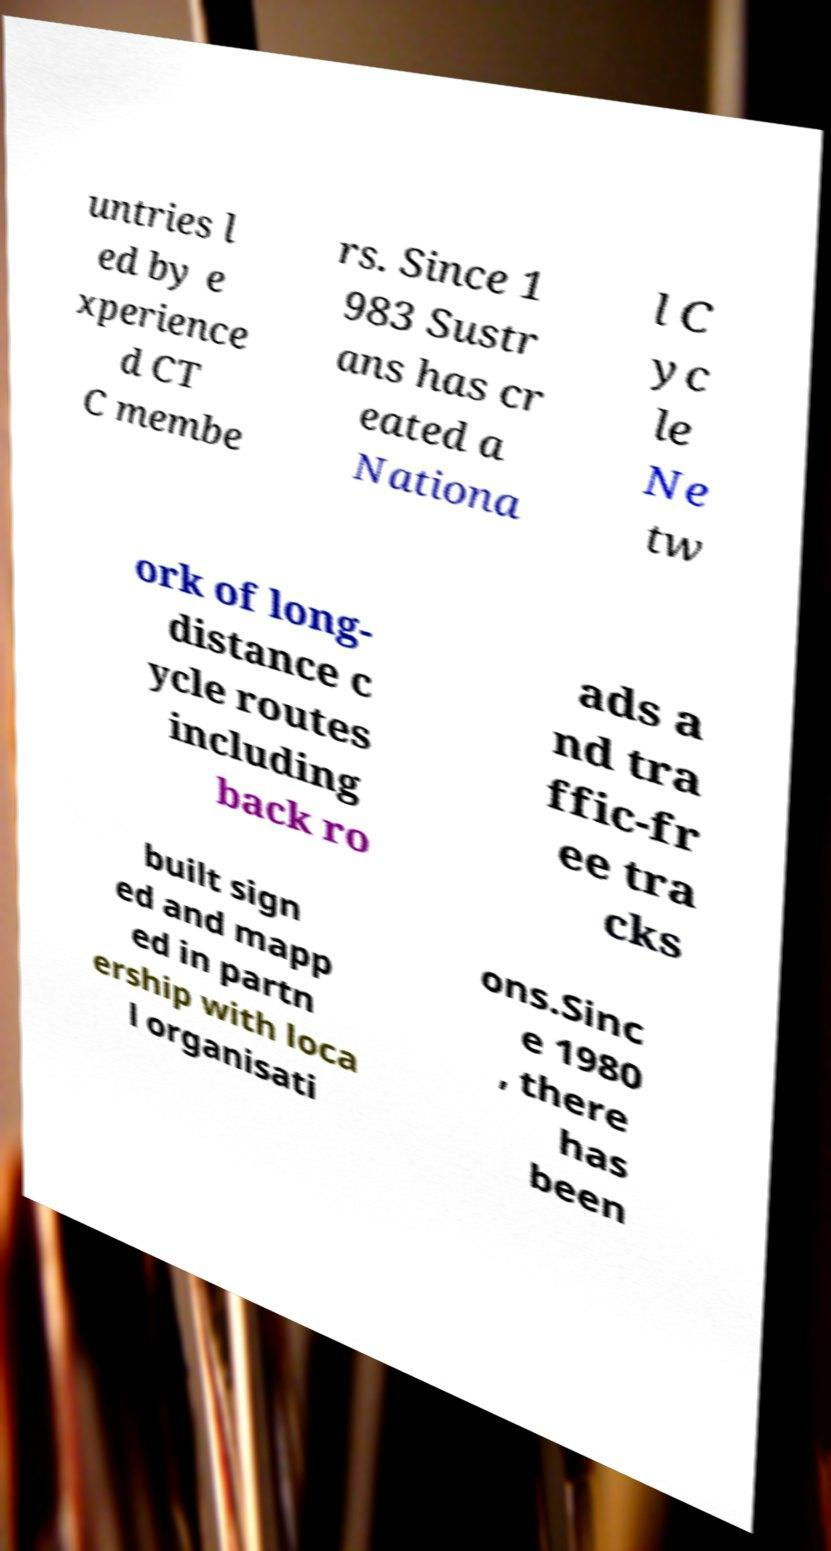What messages or text are displayed in this image? I need them in a readable, typed format. untries l ed by e xperience d CT C membe rs. Since 1 983 Sustr ans has cr eated a Nationa l C yc le Ne tw ork of long- distance c ycle routes including back ro ads a nd tra ffic-fr ee tra cks built sign ed and mapp ed in partn ership with loca l organisati ons.Sinc e 1980 , there has been 